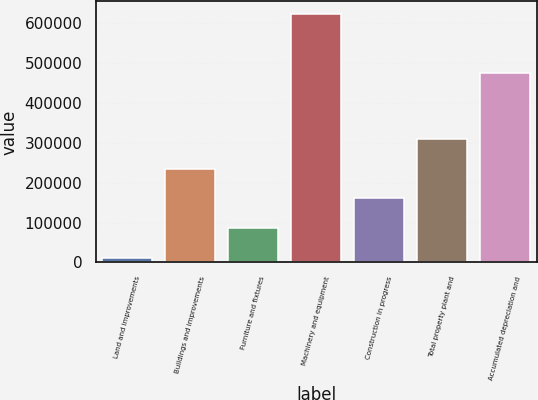<chart> <loc_0><loc_0><loc_500><loc_500><bar_chart><fcel>Land and improvements<fcel>Buildings and improvements<fcel>Furniture and fixtures<fcel>Machinery and equipment<fcel>Construction in progress<fcel>Total property plant and<fcel>Accumulated depreciation and<nl><fcel>12009<fcel>234783<fcel>86266.9<fcel>623328<fcel>160525<fcel>309041<fcel>475205<nl></chart> 